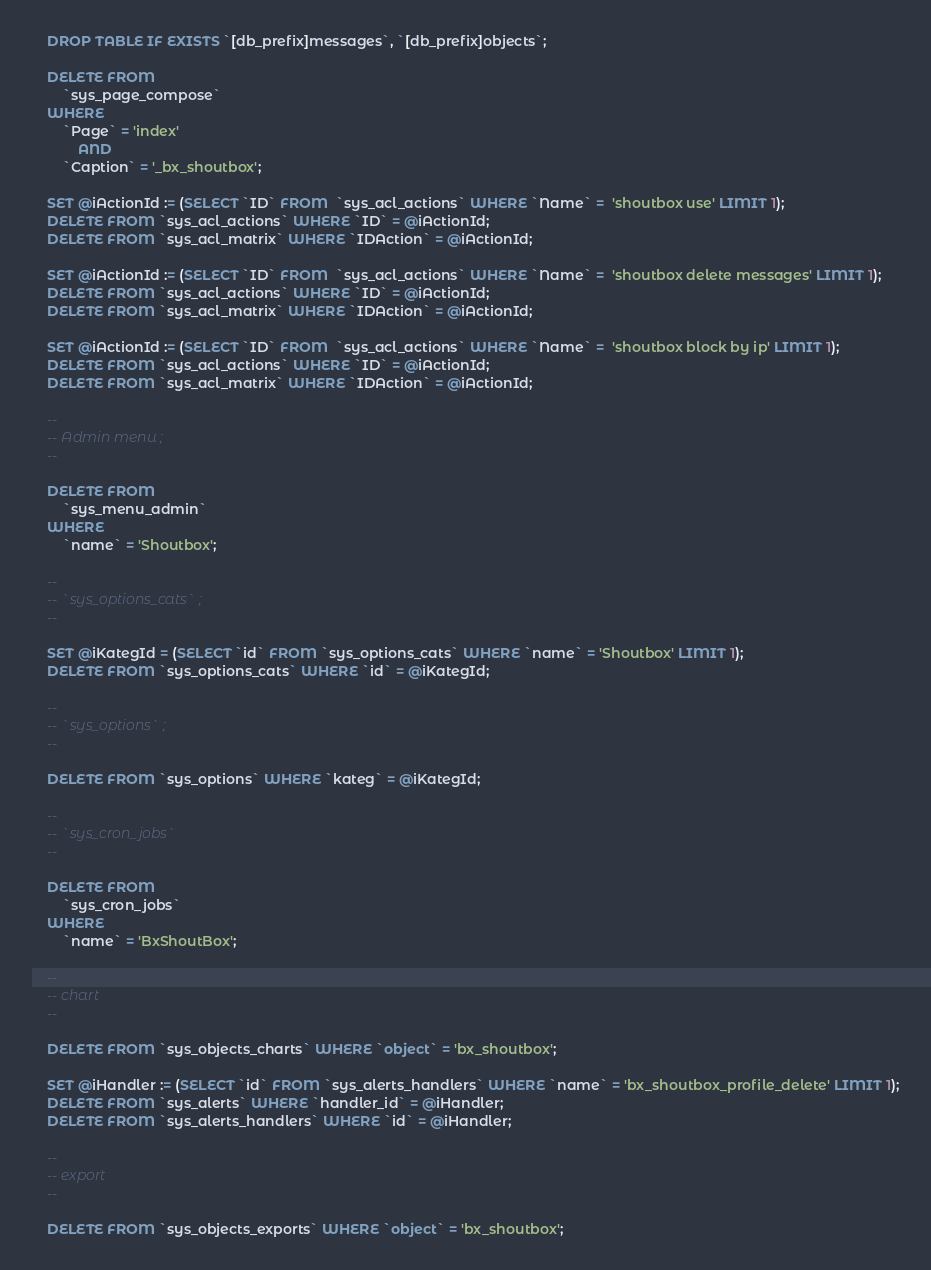<code> <loc_0><loc_0><loc_500><loc_500><_SQL_>
    DROP TABLE IF EXISTS `[db_prefix]messages`, `[db_prefix]objects`;

    DELETE FROM 
        `sys_page_compose` 
    WHERE
        `Page` = 'index'
            AND
        `Caption` = '_bx_shoutbox';

    SET @iActionId := (SELECT `ID` FROM  `sys_acl_actions` WHERE `Name` =  'shoutbox use' LIMIT 1);
    DELETE FROM `sys_acl_actions` WHERE `ID` = @iActionId;
    DELETE FROM `sys_acl_matrix` WHERE `IDAction` = @iActionId;

    SET @iActionId := (SELECT `ID` FROM  `sys_acl_actions` WHERE `Name` =  'shoutbox delete messages' LIMIT 1);
    DELETE FROM `sys_acl_actions` WHERE `ID` = @iActionId;
    DELETE FROM `sys_acl_matrix` WHERE `IDAction` = @iActionId;

    SET @iActionId := (SELECT `ID` FROM  `sys_acl_actions` WHERE `Name` =  'shoutbox block by ip' LIMIT 1);
    DELETE FROM `sys_acl_actions` WHERE `ID` = @iActionId;
    DELETE FROM `sys_acl_matrix` WHERE `IDAction` = @iActionId;

    --
    -- Admin menu ;
    --

    DELETE FROM 
        `sys_menu_admin` 
    WHERE
        `name` = 'Shoutbox';

    --
    -- `sys_options_cats` ;
    --

    SET @iKategId = (SELECT `id` FROM `sys_options_cats` WHERE `name` = 'Shoutbox' LIMIT 1);
    DELETE FROM `sys_options_cats` WHERE `id` = @iKategId;

    --
    -- `sys_options` ;
    --

    DELETE FROM `sys_options` WHERE `kateg` = @iKategId;
 
    --
    -- `sys_cron_jobs`
    --

    DELETE FROM
        `sys_cron_jobs` 
    WHERE
   		`name` = 'BxShoutBox';

    --
    -- chart
    --

    DELETE FROM `sys_objects_charts` WHERE `object` = 'bx_shoutbox';

    SET @iHandler := (SELECT `id` FROM `sys_alerts_handlers` WHERE `name` = 'bx_shoutbox_profile_delete' LIMIT 1);
    DELETE FROM `sys_alerts` WHERE `handler_id` = @iHandler;
    DELETE FROM `sys_alerts_handlers` WHERE `id` = @iHandler;

    --
    -- export
    --

    DELETE FROM `sys_objects_exports` WHERE `object` = 'bx_shoutbox';

</code> 